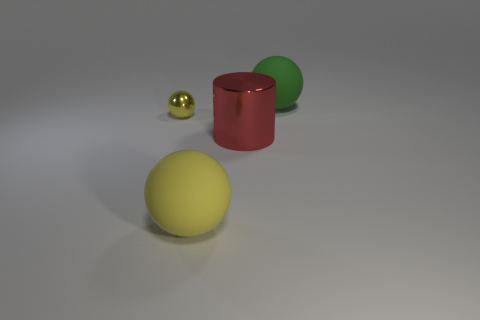Is there any other thing that has the same size as the yellow metallic thing?
Keep it short and to the point. No. There is a large ball in front of the matte ball to the right of the large yellow rubber object; what is it made of?
Keep it short and to the point. Rubber. The matte object that is the same color as the tiny shiny thing is what shape?
Ensure brevity in your answer.  Sphere. Are there any small cyan things made of the same material as the large cylinder?
Give a very brief answer. No. Is the big green ball made of the same material as the thing in front of the shiny cylinder?
Provide a succinct answer. Yes. What color is the other matte ball that is the same size as the green ball?
Offer a very short reply. Yellow. There is a yellow ball that is to the left of the large rubber sphere in front of the big green rubber object; what is its size?
Keep it short and to the point. Small. There is a large metallic cylinder; is its color the same as the big object that is behind the big metallic thing?
Keep it short and to the point. No. Is the number of big yellow matte things that are left of the metallic sphere less than the number of big spheres?
Keep it short and to the point. Yes. What number of other things are there of the same size as the shiny ball?
Provide a short and direct response. 0. 